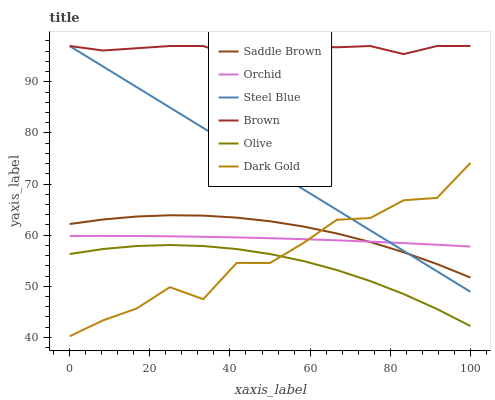Does Olive have the minimum area under the curve?
Answer yes or no. Yes. Does Brown have the maximum area under the curve?
Answer yes or no. Yes. Does Dark Gold have the minimum area under the curve?
Answer yes or no. No. Does Dark Gold have the maximum area under the curve?
Answer yes or no. No. Is Steel Blue the smoothest?
Answer yes or no. Yes. Is Dark Gold the roughest?
Answer yes or no. Yes. Is Dark Gold the smoothest?
Answer yes or no. No. Is Steel Blue the roughest?
Answer yes or no. No. Does Dark Gold have the lowest value?
Answer yes or no. Yes. Does Steel Blue have the lowest value?
Answer yes or no. No. Does Steel Blue have the highest value?
Answer yes or no. Yes. Does Dark Gold have the highest value?
Answer yes or no. No. Is Saddle Brown less than Brown?
Answer yes or no. Yes. Is Saddle Brown greater than Olive?
Answer yes or no. Yes. Does Dark Gold intersect Steel Blue?
Answer yes or no. Yes. Is Dark Gold less than Steel Blue?
Answer yes or no. No. Is Dark Gold greater than Steel Blue?
Answer yes or no. No. Does Saddle Brown intersect Brown?
Answer yes or no. No. 